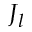Convert formula to latex. <formula><loc_0><loc_0><loc_500><loc_500>J _ { l }</formula> 